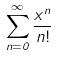Convert formula to latex. <formula><loc_0><loc_0><loc_500><loc_500>\sum _ { n = 0 } ^ { \infty } \frac { x ^ { n } } { n ! }</formula> 